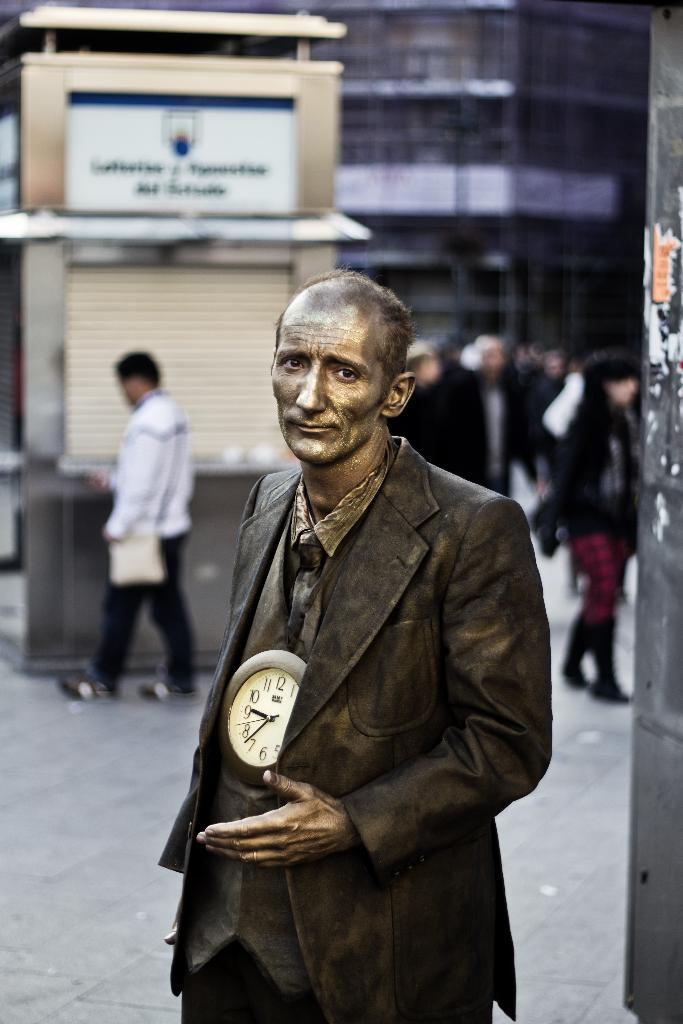Who is the main subject in the front of the image? There is a person in the front of the image. What object is near the person? There is a clock near the person. How would you describe the background of the image? The background of the image is blurred. What structures can be seen in the background? There is a building and a site in the background. What additional feature is present in the background? There is a hoarding in the background. Are there any other people visible in the image? Yes, there are people in the background. What type of oranges are being harvested by the queen in the image? There is no queen or oranges present in the image. 